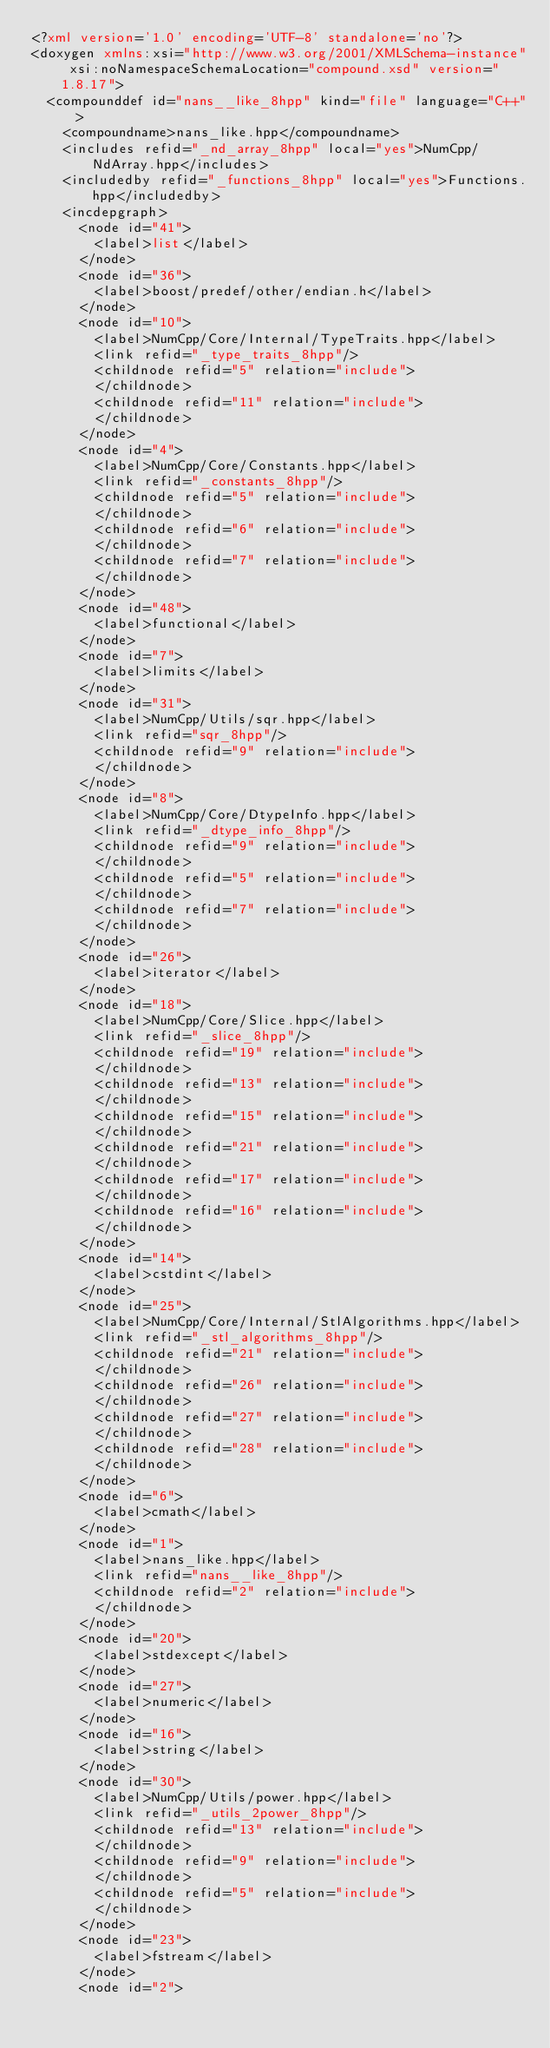Convert code to text. <code><loc_0><loc_0><loc_500><loc_500><_XML_><?xml version='1.0' encoding='UTF-8' standalone='no'?>
<doxygen xmlns:xsi="http://www.w3.org/2001/XMLSchema-instance" xsi:noNamespaceSchemaLocation="compound.xsd" version="1.8.17">
  <compounddef id="nans__like_8hpp" kind="file" language="C++">
    <compoundname>nans_like.hpp</compoundname>
    <includes refid="_nd_array_8hpp" local="yes">NumCpp/NdArray.hpp</includes>
    <includedby refid="_functions_8hpp" local="yes">Functions.hpp</includedby>
    <incdepgraph>
      <node id="41">
        <label>list</label>
      </node>
      <node id="36">
        <label>boost/predef/other/endian.h</label>
      </node>
      <node id="10">
        <label>NumCpp/Core/Internal/TypeTraits.hpp</label>
        <link refid="_type_traits_8hpp"/>
        <childnode refid="5" relation="include">
        </childnode>
        <childnode refid="11" relation="include">
        </childnode>
      </node>
      <node id="4">
        <label>NumCpp/Core/Constants.hpp</label>
        <link refid="_constants_8hpp"/>
        <childnode refid="5" relation="include">
        </childnode>
        <childnode refid="6" relation="include">
        </childnode>
        <childnode refid="7" relation="include">
        </childnode>
      </node>
      <node id="48">
        <label>functional</label>
      </node>
      <node id="7">
        <label>limits</label>
      </node>
      <node id="31">
        <label>NumCpp/Utils/sqr.hpp</label>
        <link refid="sqr_8hpp"/>
        <childnode refid="9" relation="include">
        </childnode>
      </node>
      <node id="8">
        <label>NumCpp/Core/DtypeInfo.hpp</label>
        <link refid="_dtype_info_8hpp"/>
        <childnode refid="9" relation="include">
        </childnode>
        <childnode refid="5" relation="include">
        </childnode>
        <childnode refid="7" relation="include">
        </childnode>
      </node>
      <node id="26">
        <label>iterator</label>
      </node>
      <node id="18">
        <label>NumCpp/Core/Slice.hpp</label>
        <link refid="_slice_8hpp"/>
        <childnode refid="19" relation="include">
        </childnode>
        <childnode refid="13" relation="include">
        </childnode>
        <childnode refid="15" relation="include">
        </childnode>
        <childnode refid="21" relation="include">
        </childnode>
        <childnode refid="17" relation="include">
        </childnode>
        <childnode refid="16" relation="include">
        </childnode>
      </node>
      <node id="14">
        <label>cstdint</label>
      </node>
      <node id="25">
        <label>NumCpp/Core/Internal/StlAlgorithms.hpp</label>
        <link refid="_stl_algorithms_8hpp"/>
        <childnode refid="21" relation="include">
        </childnode>
        <childnode refid="26" relation="include">
        </childnode>
        <childnode refid="27" relation="include">
        </childnode>
        <childnode refid="28" relation="include">
        </childnode>
      </node>
      <node id="6">
        <label>cmath</label>
      </node>
      <node id="1">
        <label>nans_like.hpp</label>
        <link refid="nans__like_8hpp"/>
        <childnode refid="2" relation="include">
        </childnode>
      </node>
      <node id="20">
        <label>stdexcept</label>
      </node>
      <node id="27">
        <label>numeric</label>
      </node>
      <node id="16">
        <label>string</label>
      </node>
      <node id="30">
        <label>NumCpp/Utils/power.hpp</label>
        <link refid="_utils_2power_8hpp"/>
        <childnode refid="13" relation="include">
        </childnode>
        <childnode refid="9" relation="include">
        </childnode>
        <childnode refid="5" relation="include">
        </childnode>
      </node>
      <node id="23">
        <label>fstream</label>
      </node>
      <node id="2"></code> 